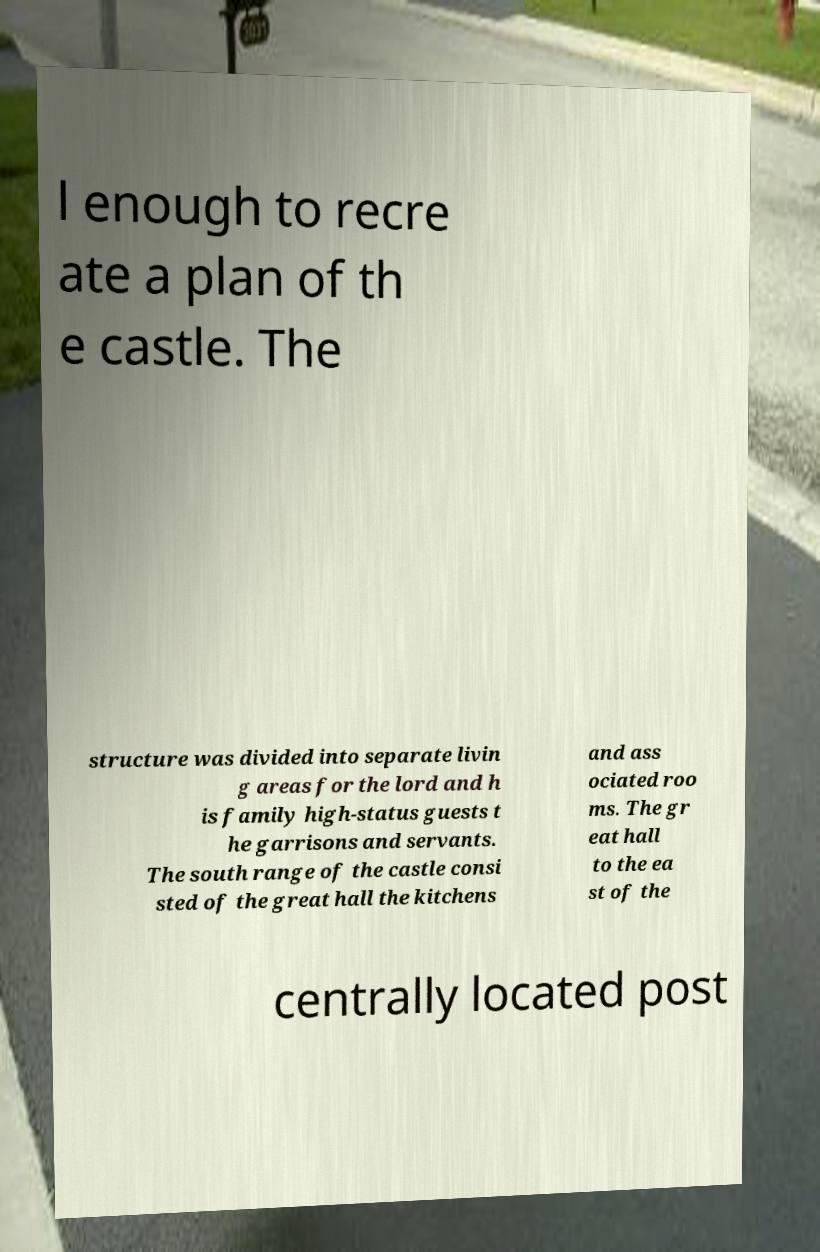Could you assist in decoding the text presented in this image and type it out clearly? l enough to recre ate a plan of th e castle. The structure was divided into separate livin g areas for the lord and h is family high-status guests t he garrisons and servants. The south range of the castle consi sted of the great hall the kitchens and ass ociated roo ms. The gr eat hall to the ea st of the centrally located post 